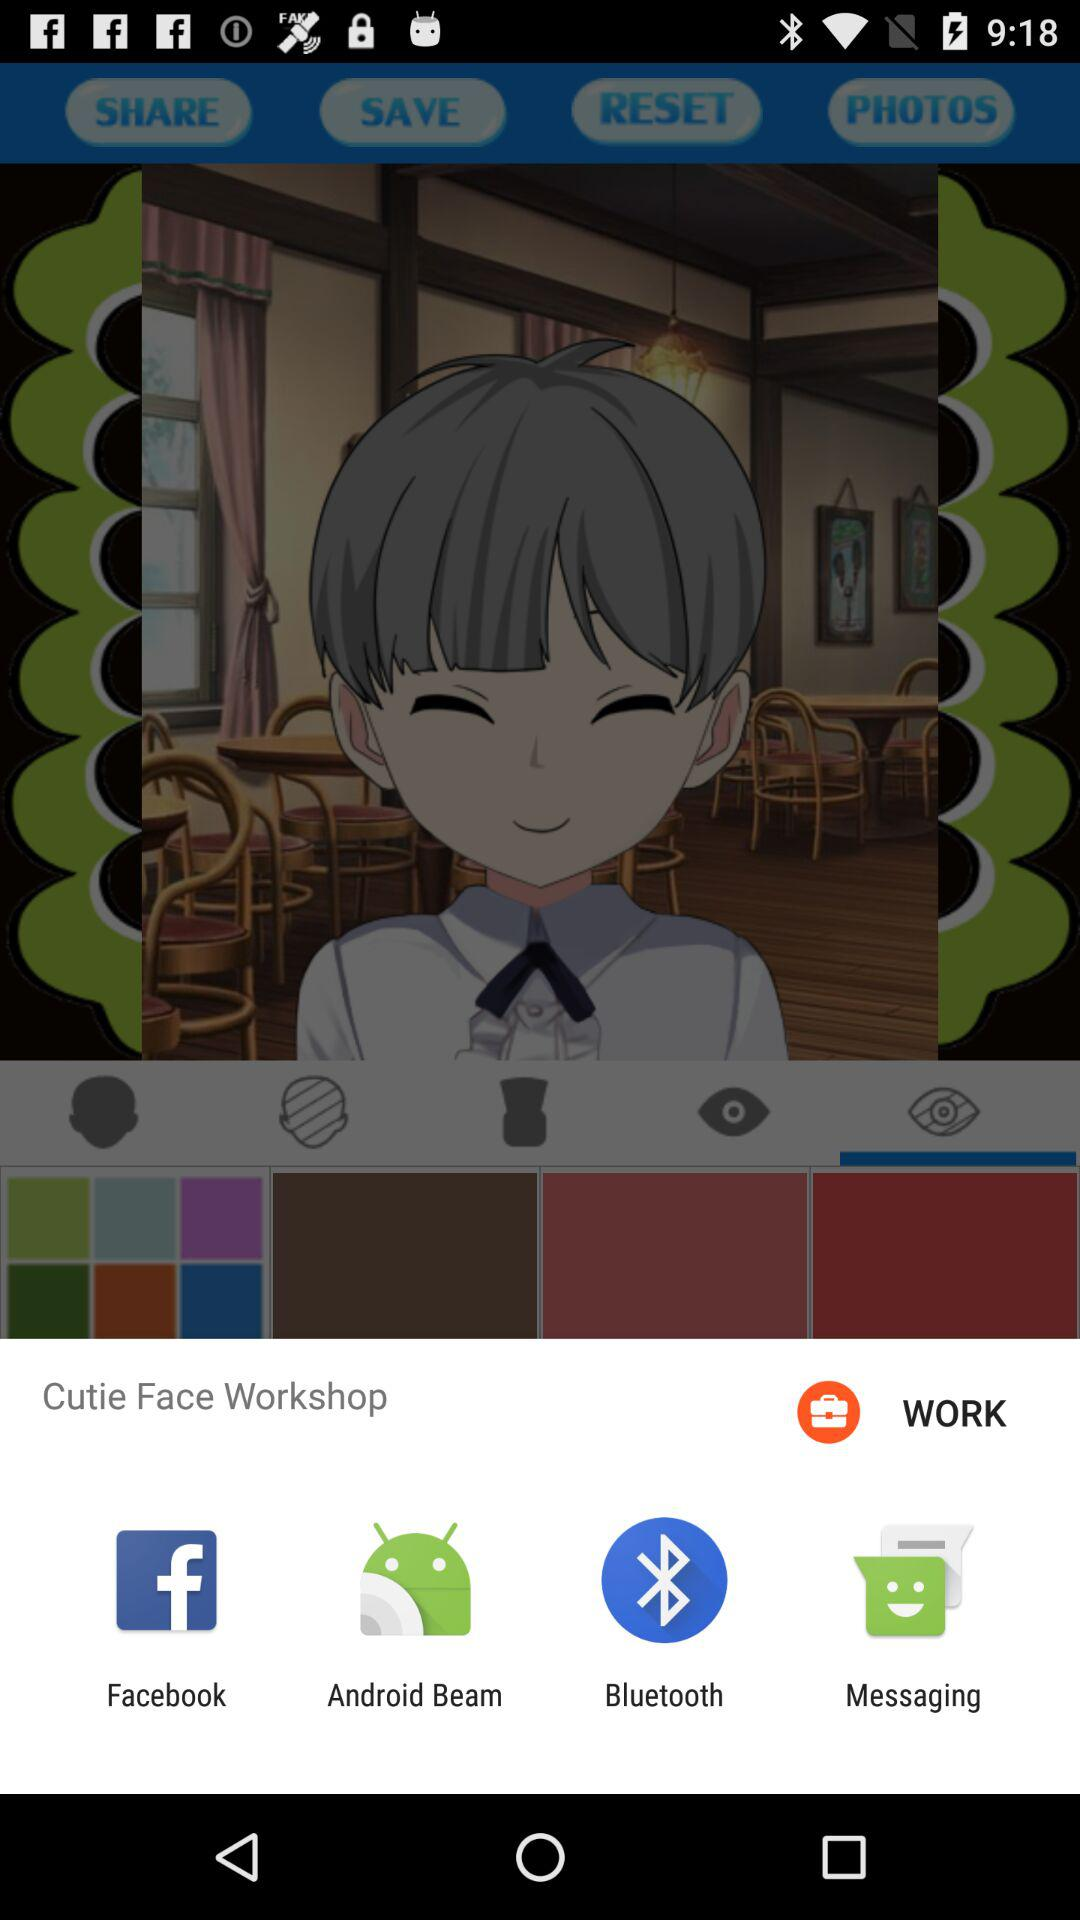What are the different mediums that can be used to share? The different mediums are "Facebook", "Android Beam", "Bluetooth" and "Messaging". 